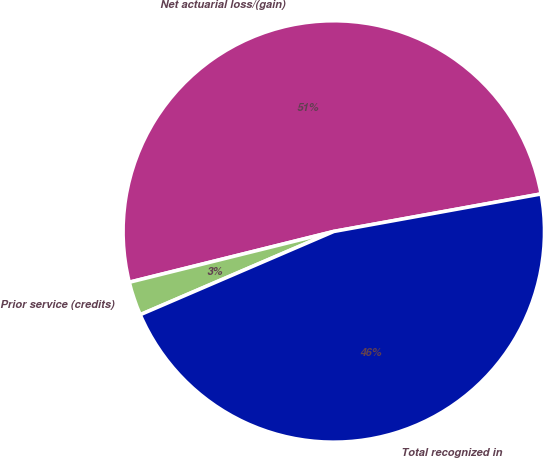Convert chart to OTSL. <chart><loc_0><loc_0><loc_500><loc_500><pie_chart><fcel>Net actuarial loss/(gain)<fcel>Prior service (credits)<fcel>Total recognized in<nl><fcel>51.03%<fcel>2.59%<fcel>46.39%<nl></chart> 